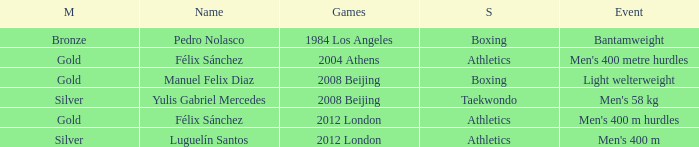I'm looking to parse the entire table for insights. Could you assist me with that? {'header': ['M', 'Name', 'Games', 'S', 'Event'], 'rows': [['Bronze', 'Pedro Nolasco', '1984 Los Angeles', 'Boxing', 'Bantamweight'], ['Gold', 'Félix Sánchez', '2004 Athens', 'Athletics', "Men's 400 metre hurdles"], ['Gold', 'Manuel Felix Diaz', '2008 Beijing', 'Boxing', 'Light welterweight'], ['Silver', 'Yulis Gabriel Mercedes', '2008 Beijing', 'Taekwondo', "Men's 58 kg"], ['Gold', 'Félix Sánchez', '2012 London', 'Athletics', "Men's 400 m hurdles"], ['Silver', 'Luguelín Santos', '2012 London', 'Athletics', "Men's 400 m"]]} Which Medal had a Games of 2008 beijing, and a Sport of taekwondo? Silver. 